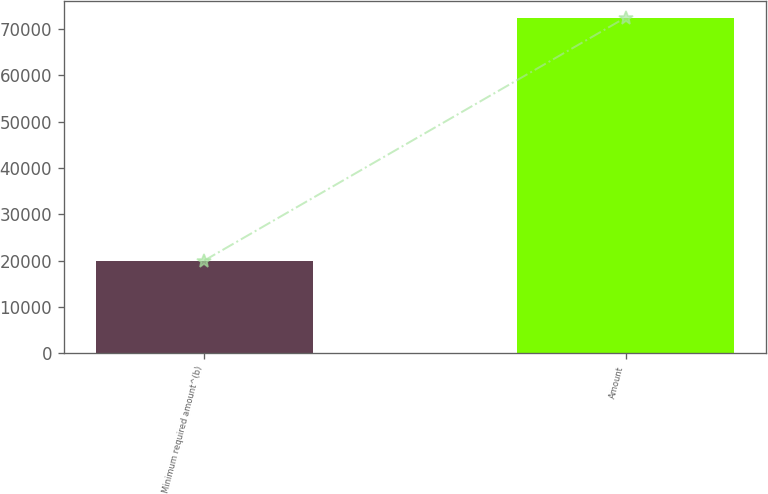Convert chart. <chart><loc_0><loc_0><loc_500><loc_500><bar_chart><fcel>Minimum required amount^(b)<fcel>Amount<nl><fcel>20020<fcel>72475<nl></chart> 